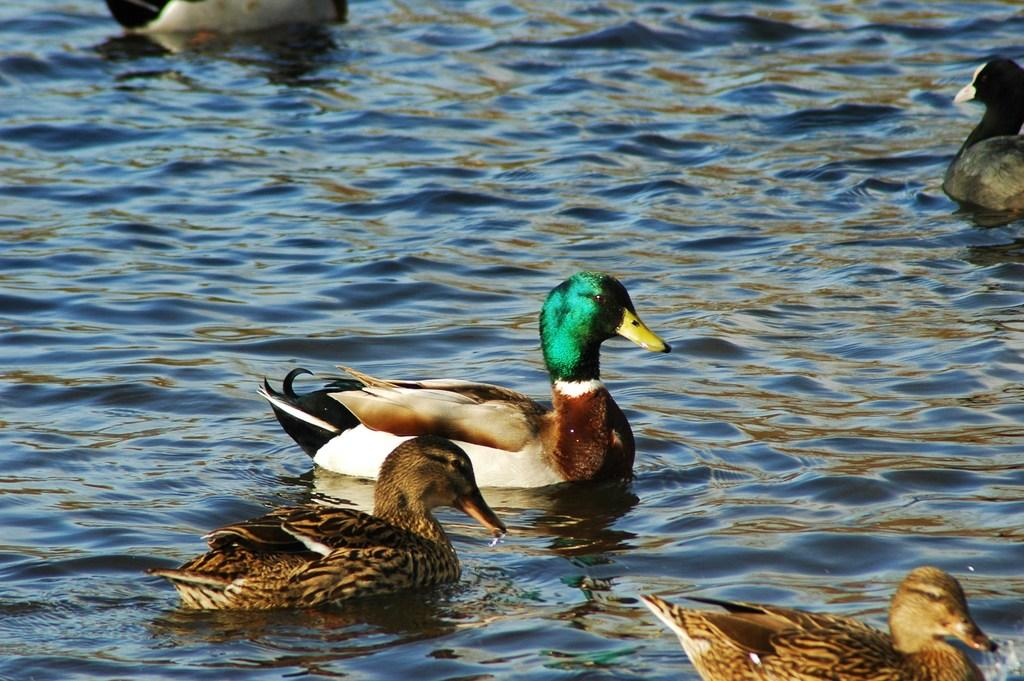What animals are present in the image? There are ducks in the image. Where are the ducks located? The ducks are on the water. Which actor is performing in the duck show at the zoo in the image? There is no actor or duck show at a zoo present in the image; it simply features ducks on the water. What type of tooth can be seen in the image? There are no teeth visible in the image, as it features ducks on the water and ducks do not have teeth. 